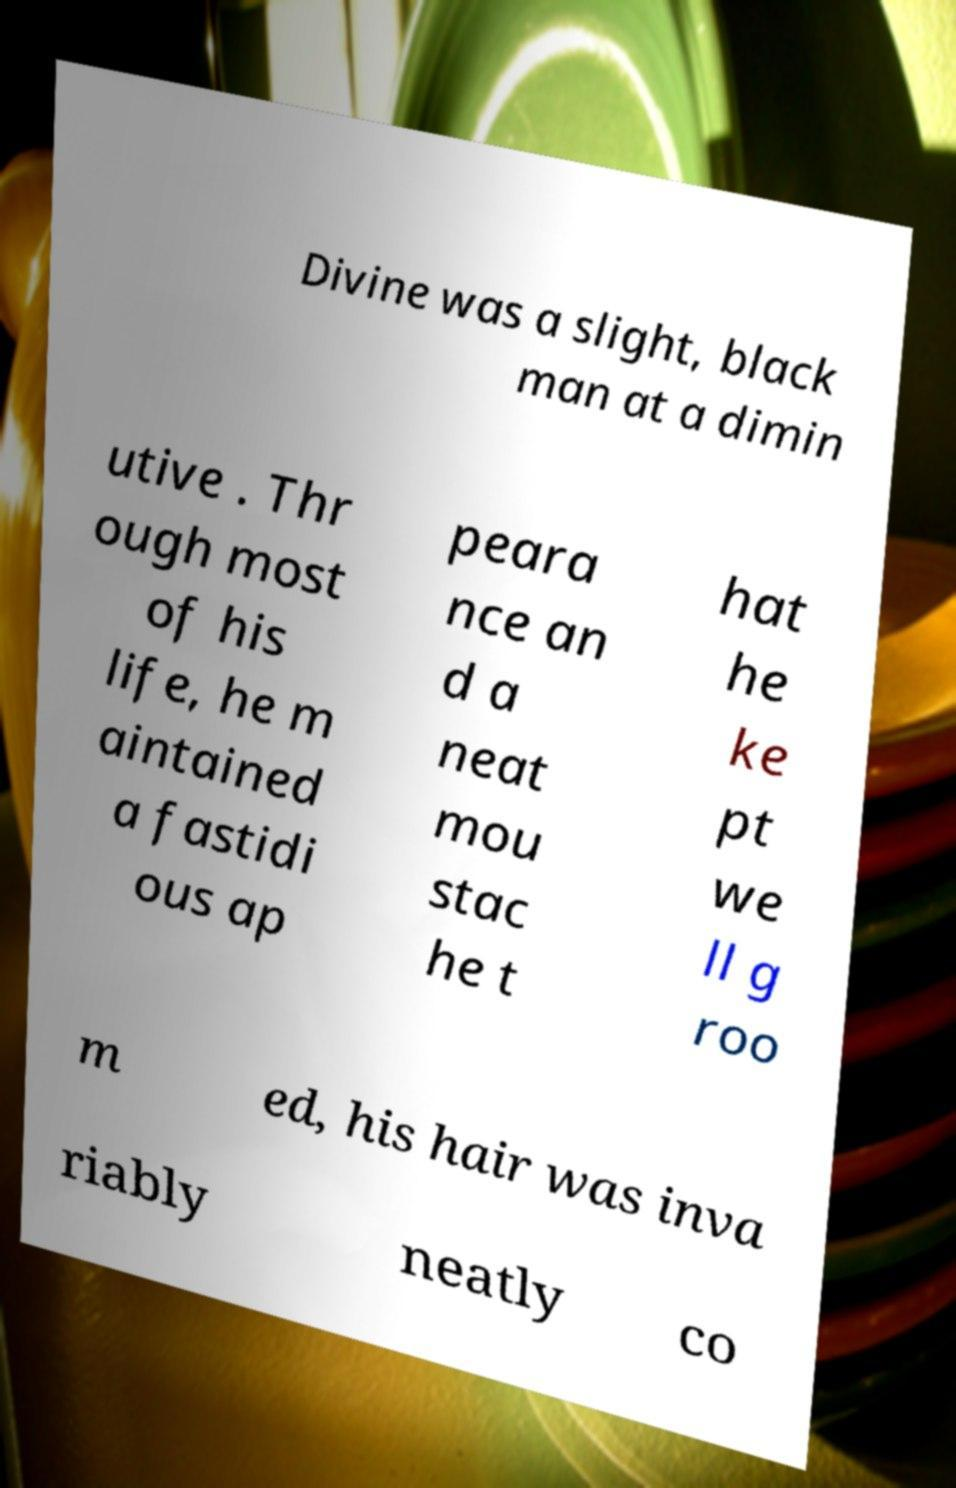Can you read and provide the text displayed in the image?This photo seems to have some interesting text. Can you extract and type it out for me? Divine was a slight, black man at a dimin utive . Thr ough most of his life, he m aintained a fastidi ous ap peara nce an d a neat mou stac he t hat he ke pt we ll g roo m ed, his hair was inva riably neatly co 